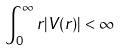<formula> <loc_0><loc_0><loc_500><loc_500>\int _ { 0 } ^ { \infty } r | V ( r ) | < \infty</formula> 